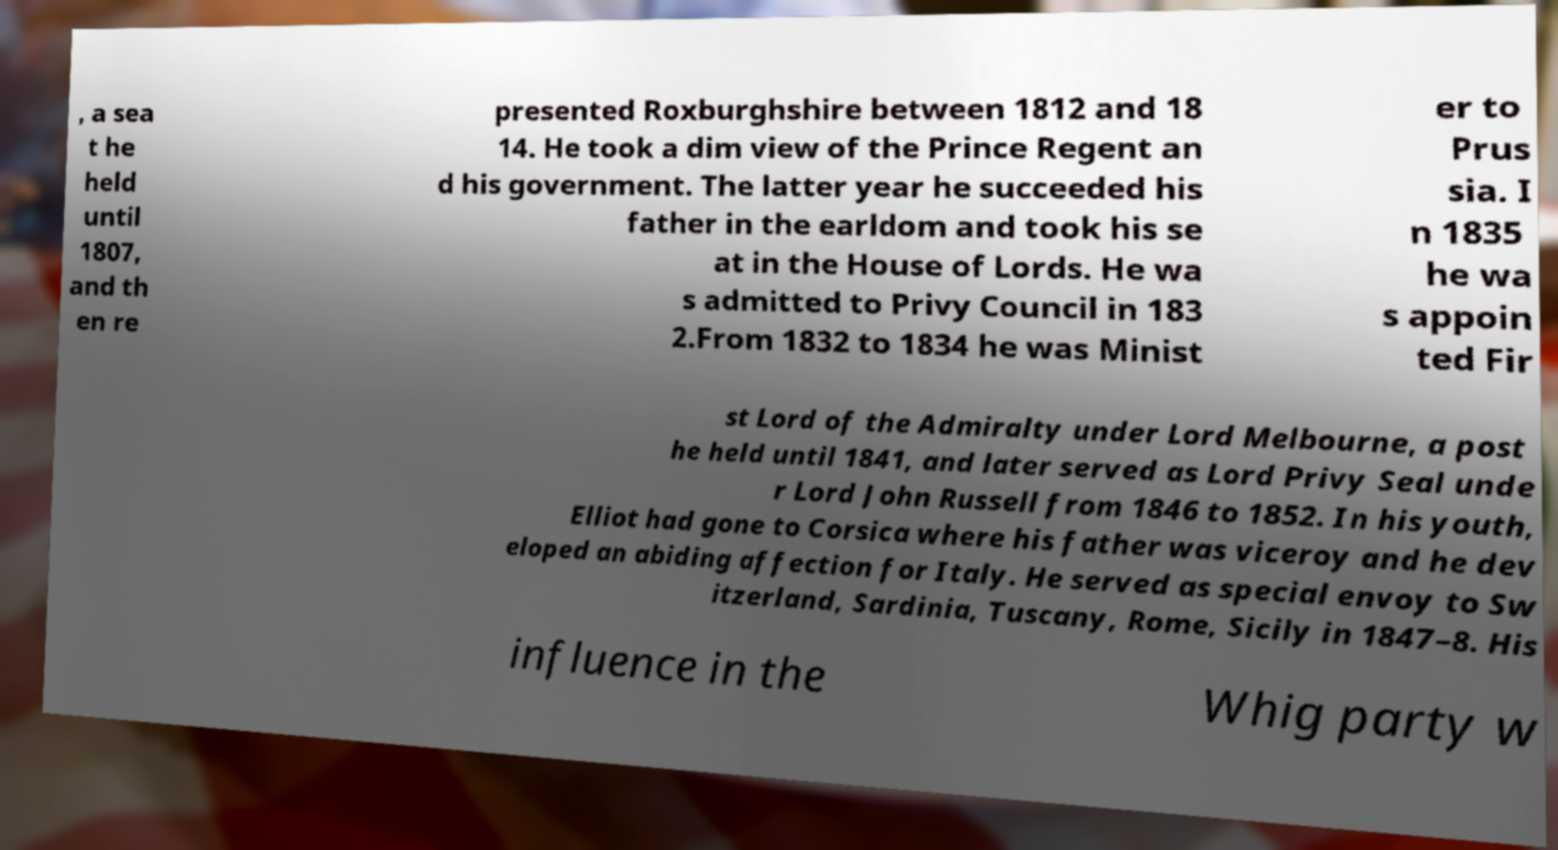Could you assist in decoding the text presented in this image and type it out clearly? , a sea t he held until 1807, and th en re presented Roxburghshire between 1812 and 18 14. He took a dim view of the Prince Regent an d his government. The latter year he succeeded his father in the earldom and took his se at in the House of Lords. He wa s admitted to Privy Council in 183 2.From 1832 to 1834 he was Minist er to Prus sia. I n 1835 he wa s appoin ted Fir st Lord of the Admiralty under Lord Melbourne, a post he held until 1841, and later served as Lord Privy Seal unde r Lord John Russell from 1846 to 1852. In his youth, Elliot had gone to Corsica where his father was viceroy and he dev eloped an abiding affection for Italy. He served as special envoy to Sw itzerland, Sardinia, Tuscany, Rome, Sicily in 1847–8. His influence in the Whig party w 